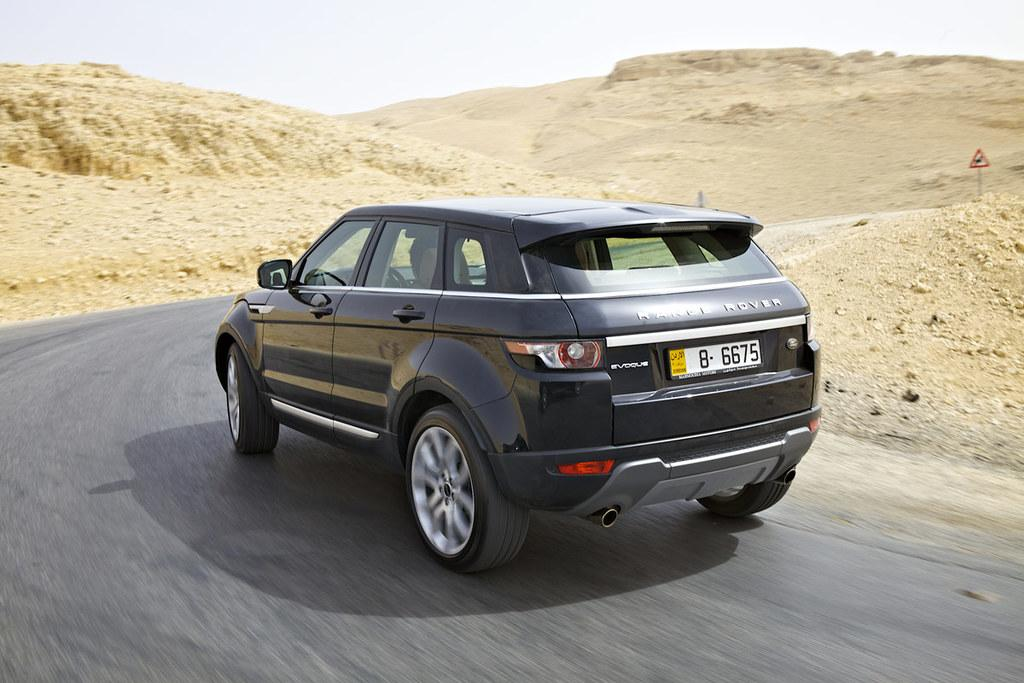What type of landscape can be seen in the image? There are hills in the image. What mode of transportation is present in the image? There is a car in the image. What is the car driving on? There is a road in the image. What object can be seen near the car? There is a board in the image. What can be seen in the background of the image? The sky is visible in the background of the image. What type of curtain can be seen hanging from the hills in the image? There is no curtain present in the image; it features hills, a car, a road, a board, and the sky. 